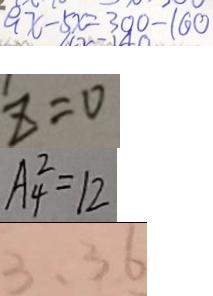<formula> <loc_0><loc_0><loc_500><loc_500>9 x - 5 x = 3 0 0 - 1 6 0 
 z = 0 
 A ^ { 2 } _ { 4 } = 1 2 
 3 , 3 6</formula> 